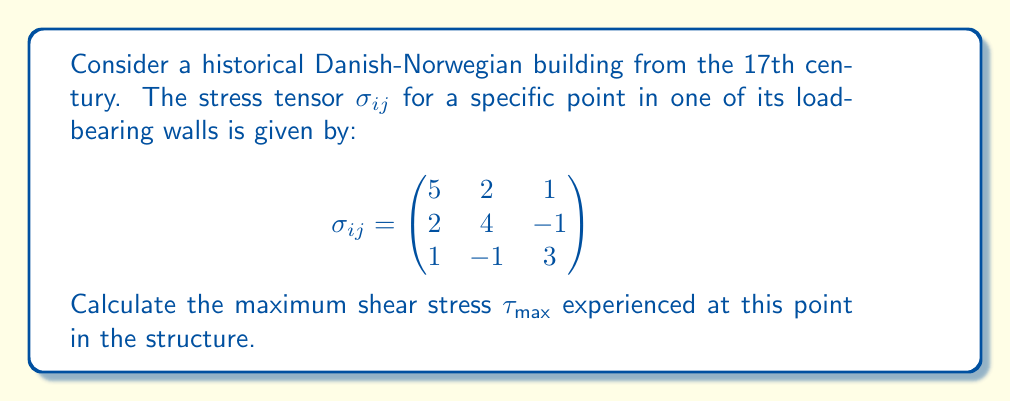Teach me how to tackle this problem. To find the maximum shear stress, we need to follow these steps:

1) First, we need to calculate the principal stresses. These are the eigenvalues of the stress tensor.

2) The characteristic equation for the eigenvalues is:
   $$\det(\sigma_{ij} - \lambda I) = 0$$

3) Expanding this determinant:
   $$\begin{vmatrix}
   5-\lambda & 2 & 1 \\
   2 & 4-\lambda & -1 \\
   1 & -1 & 3-\lambda
   \end{vmatrix} = 0$$

4) This gives us the cubic equation:
   $$-\lambda^3 + 12\lambda^2 - 41\lambda + 38 = 0$$

5) Solving this equation (using numerical methods or a calculator), we get the eigenvalues:
   $$\lambda_1 \approx 7.05, \lambda_2 \approx 3.83, \lambda_3 \approx 1.12$$

6) The maximum shear stress is given by the formula:
   $$\tau_{max} = \frac{\lambda_{max} - \lambda_{min}}{2}$$

7) Therefore:
   $$\tau_{max} = \frac{7.05 - 1.12}{2} \approx 2.965$$
Answer: $\tau_{max} \approx 2.965$ 